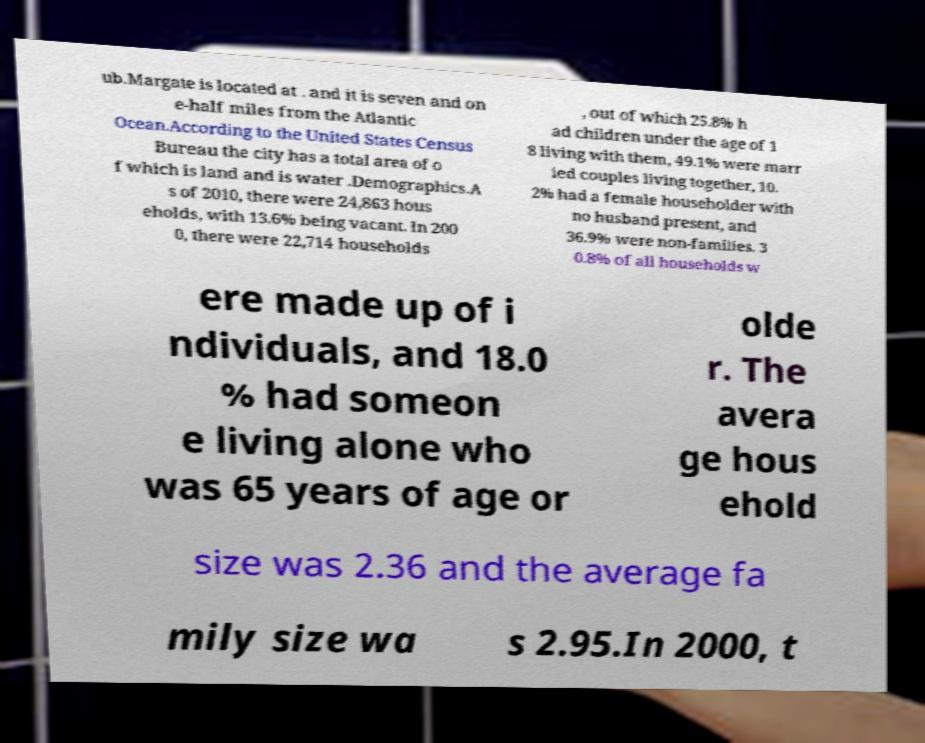Could you assist in decoding the text presented in this image and type it out clearly? ub.Margate is located at . and it is seven and on e-half miles from the Atlantic Ocean.According to the United States Census Bureau the city has a total area of o f which is land and is water .Demographics.A s of 2010, there were 24,863 hous eholds, with 13.6% being vacant. In 200 0, there were 22,714 households , out of which 25.8% h ad children under the age of 1 8 living with them, 49.1% were marr ied couples living together, 10. 2% had a female householder with no husband present, and 36.9% were non-families. 3 0.8% of all households w ere made up of i ndividuals, and 18.0 % had someon e living alone who was 65 years of age or olde r. The avera ge hous ehold size was 2.36 and the average fa mily size wa s 2.95.In 2000, t 